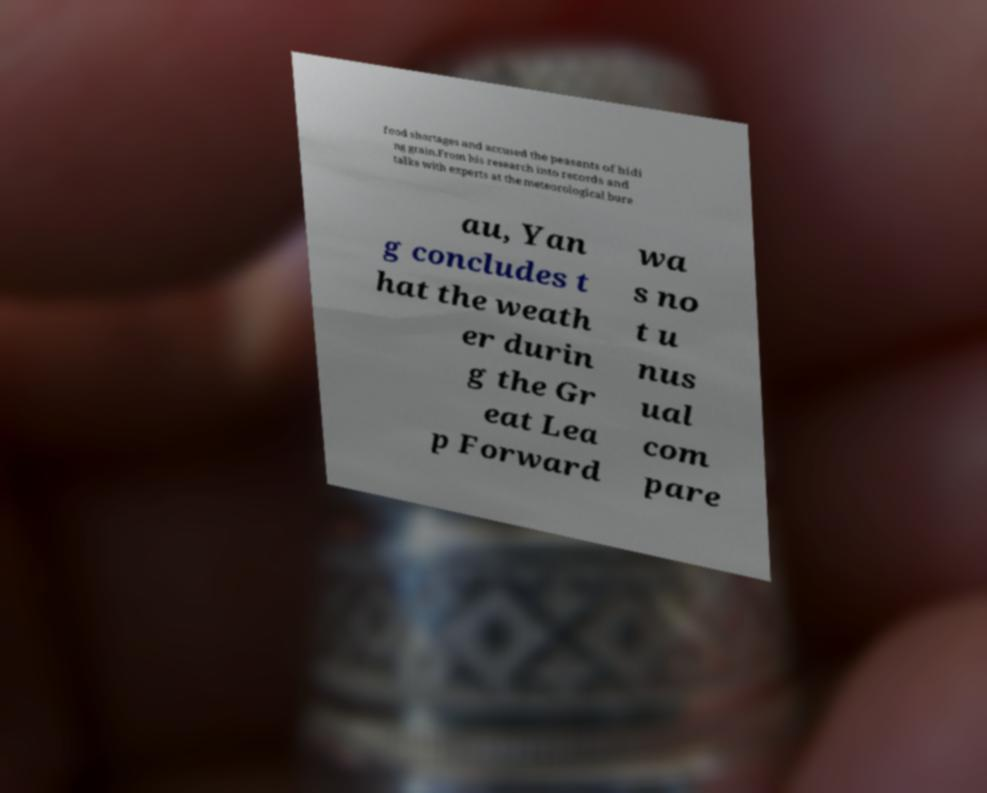For documentation purposes, I need the text within this image transcribed. Could you provide that? food shortages and accused the peasants of hidi ng grain.From his research into records and talks with experts at the meteorological bure au, Yan g concludes t hat the weath er durin g the Gr eat Lea p Forward wa s no t u nus ual com pare 